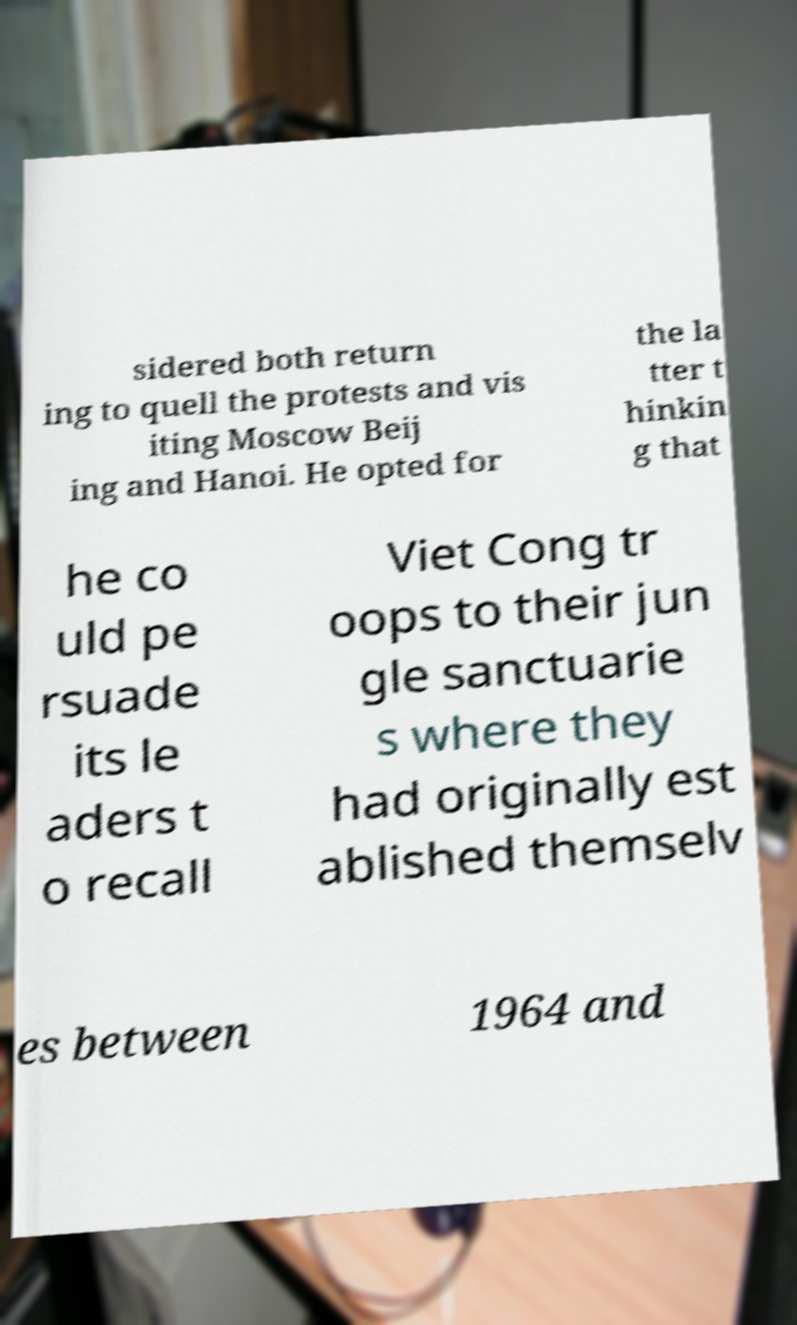I need the written content from this picture converted into text. Can you do that? sidered both return ing to quell the protests and vis iting Moscow Beij ing and Hanoi. He opted for the la tter t hinkin g that he co uld pe rsuade its le aders t o recall Viet Cong tr oops to their jun gle sanctuarie s where they had originally est ablished themselv es between 1964 and 